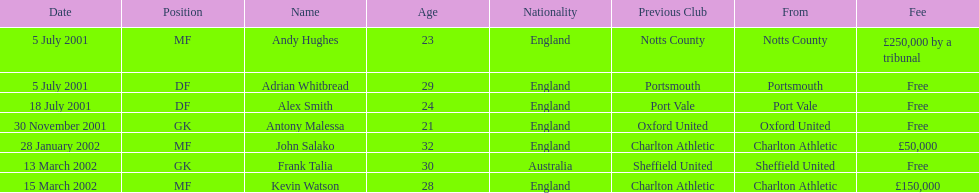Who transferred before 1 august 2001? Andy Hughes, Adrian Whitbread, Alex Smith. 